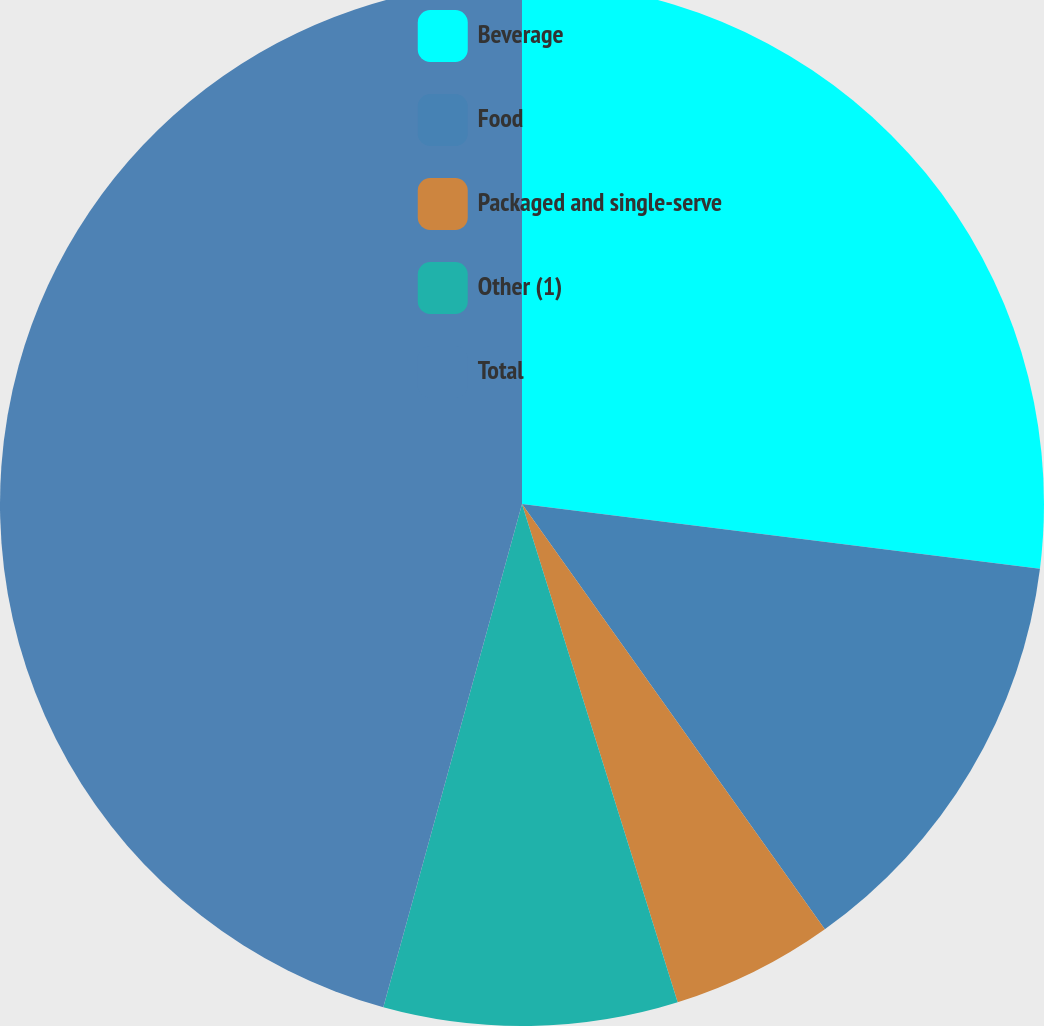Convert chart to OTSL. <chart><loc_0><loc_0><loc_500><loc_500><pie_chart><fcel>Beverage<fcel>Food<fcel>Packaged and single-serve<fcel>Other (1)<fcel>Total<nl><fcel>26.98%<fcel>13.17%<fcel>5.03%<fcel>9.1%<fcel>45.72%<nl></chart> 